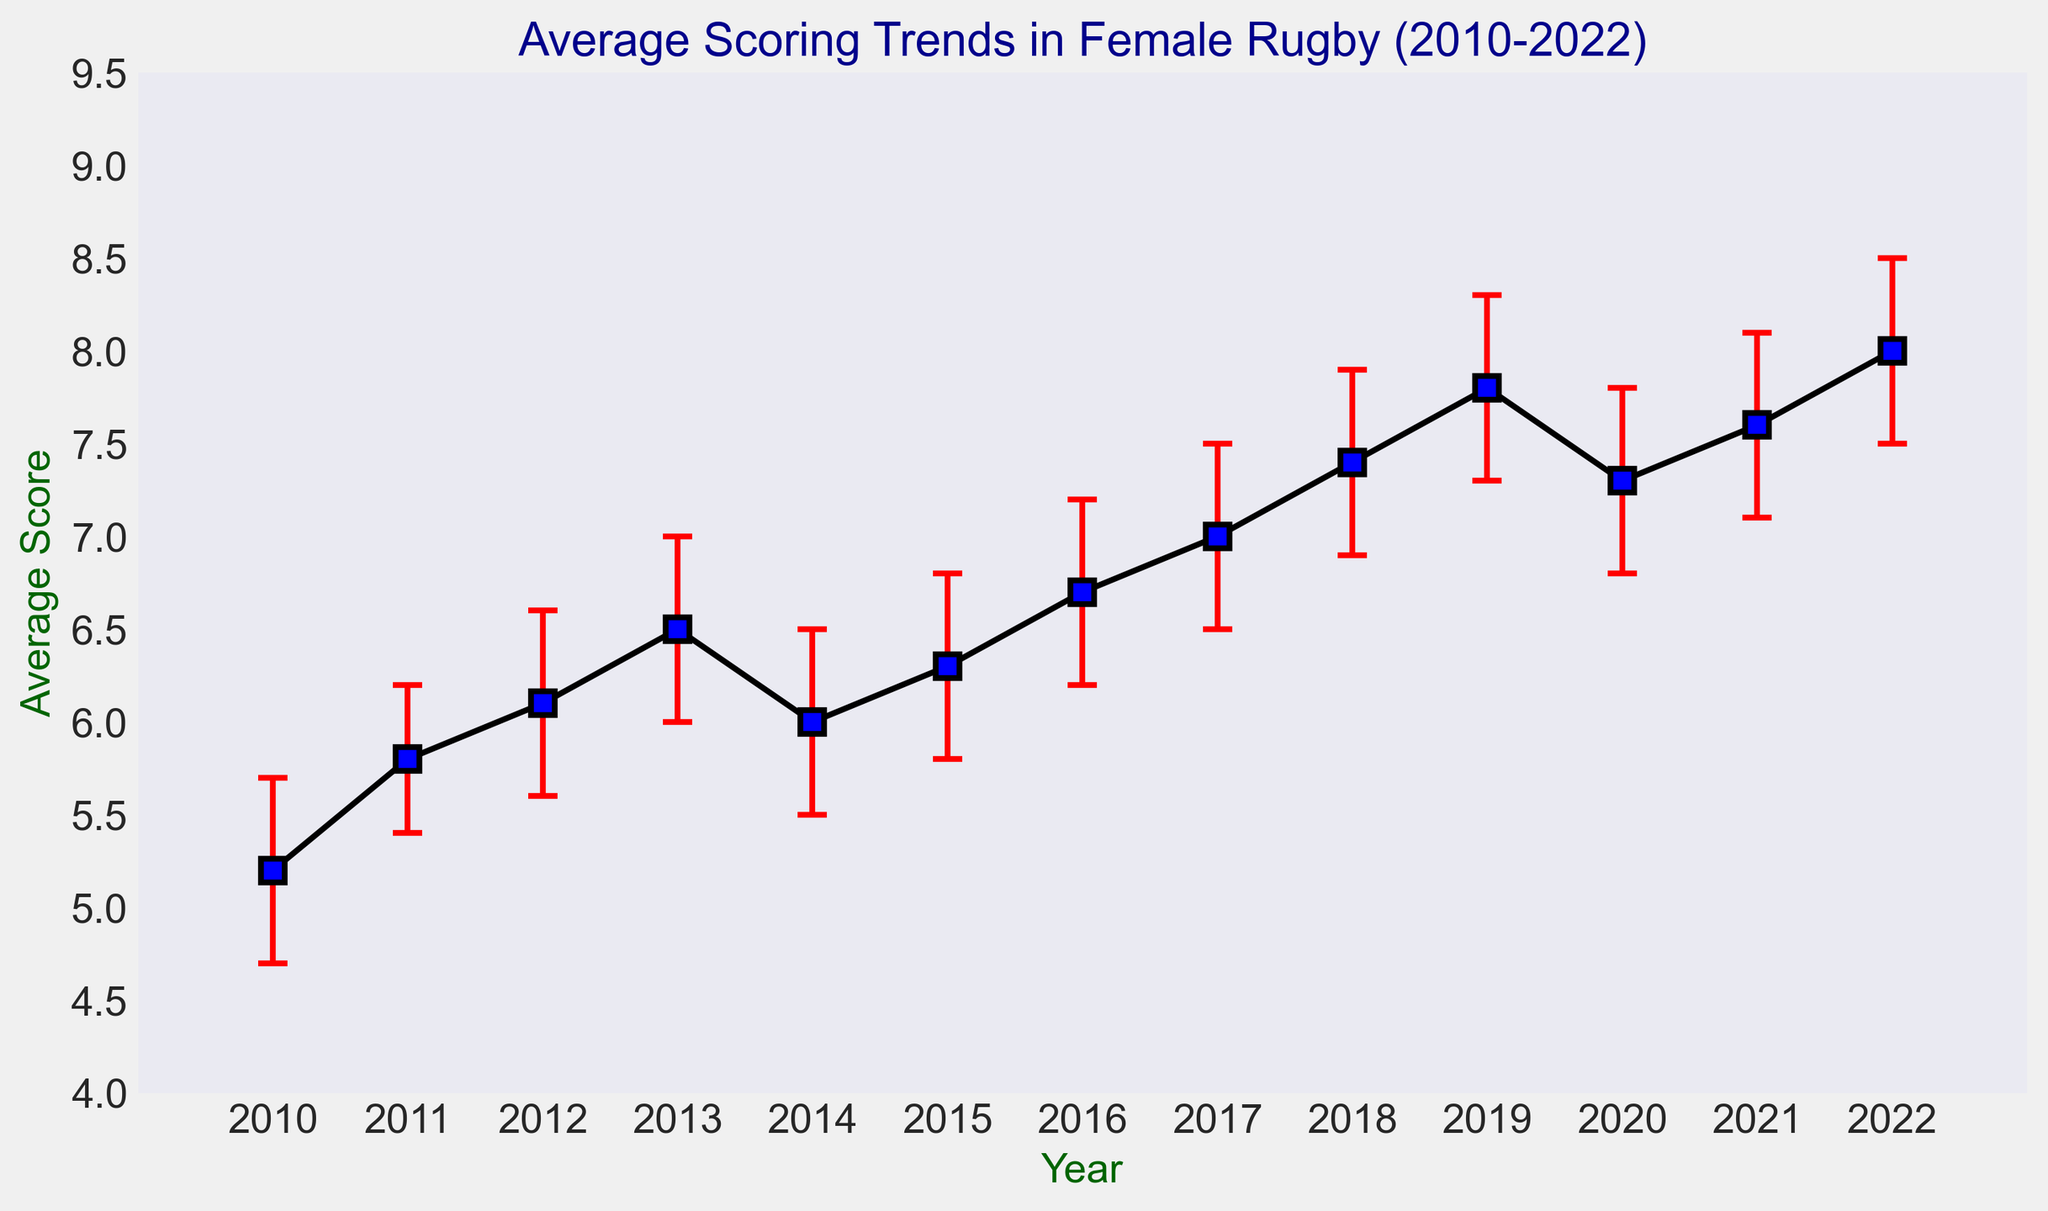What is the highest average score recorded between 2010 and 2022? First, identify the highest average score value from the plot. The highest point on the line plot indicates it was in 2022, with an average score of 8.0.
Answer: 8.0 Between which years did the average scoring trend show the most significant increase? To find the most significant increase, calculate the difference between consecutive years. The largest increase occurred between 2012 and 2013 (6.1 to 6.5).
Answer: Between 2012 and 2013 How does the average score in 2022 compare to 2010? The average score in 2010 was 5.2, while in 2022, it was 8.0. Comparing these values, 2022 has a higher average score by 8.0 - 5.2 = 2.8.
Answer: 2022 is higher by 2.8 What is the average score trend's overall increase from 2010 to 2022? The average score increased from 5.2 in 2010 to 8.0 in 2022. The overall increase is 8.0 - 5.2 = 2.8.
Answer: An increase of 2.8 In which year was the average score lowest? Observe the plot to find the lowest average score. The year with the lowest average score is 2010, with an average of 5.2.
Answer: 2010 Which year had the highest variability in average scores, based on error bars? Find the year with the longest error bar length. The longest error bar is in 2022, indicating the highest variability.
Answer: 2022 By how much did the average score change from 2020 to 2021? The average score in 2020 was 7.3, and in 2021, it was 7.6. The change is 7.6 - 7.3 = 0.3.
Answer: Increased by 0.3 What was the average score in the middle year of the data range, 2016? From the plot, locate the year 2016 and note the average score, which is 6.7.
Answer: 6.7 Which years show a decrease in average scores compared to the previous year(s)? Analyze the plot to find years where the line goes downward. The decreases occur from 2013 to 2014 (6.5 to 6.0) and from 2019 to 2020 (7.8 to 7.3).
Answer: 2014 and 2020 